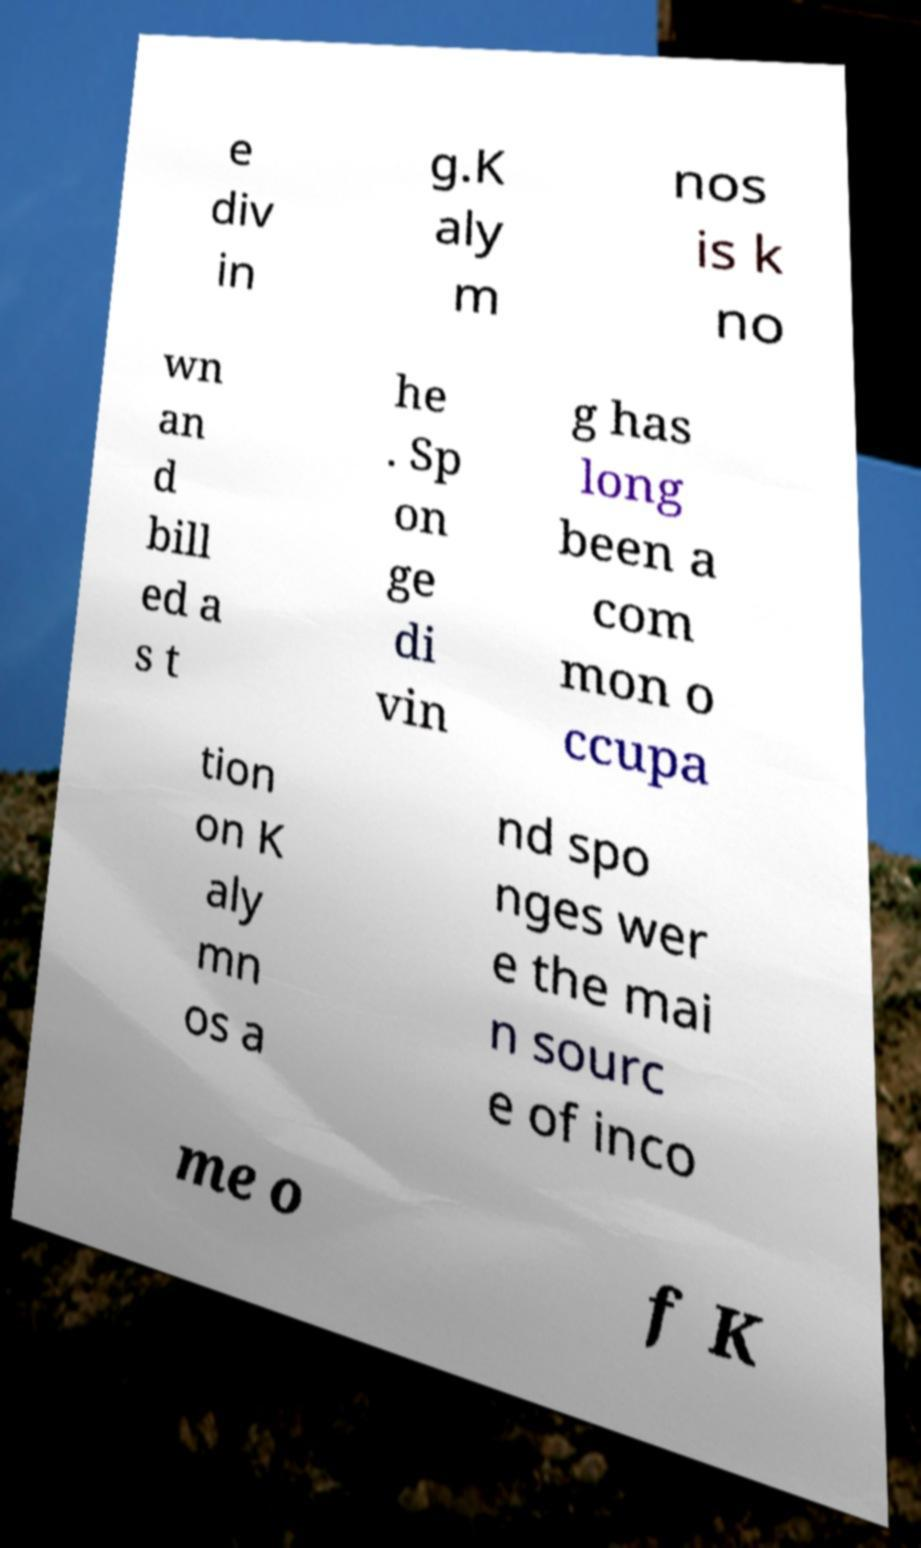Can you read and provide the text displayed in the image?This photo seems to have some interesting text. Can you extract and type it out for me? e div in g.K aly m nos is k no wn an d bill ed a s t he . Sp on ge di vin g has long been a com mon o ccupa tion on K aly mn os a nd spo nges wer e the mai n sourc e of inco me o f K 